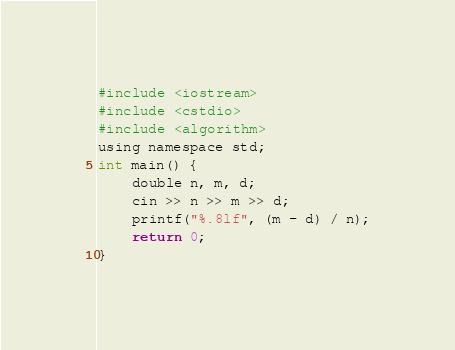Convert code to text. <code><loc_0><loc_0><loc_500><loc_500><_Python_>#include <iostream>
#include <cstdio>
#include <algorithm>
using namespace std;
int main() {
    double n, m, d;
    cin >> n >> m >> d;
    printf("%.8lf", (m - d) / n);
    return 0;
}</code> 